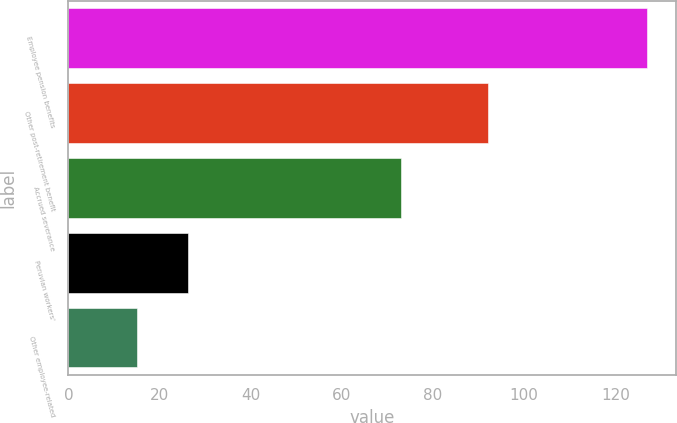Convert chart to OTSL. <chart><loc_0><loc_0><loc_500><loc_500><bar_chart><fcel>Employee pension benefits<fcel>Other post-retirement benefit<fcel>Accrued severance<fcel>Peruvian workers'<fcel>Other employee-related<nl><fcel>127<fcel>92<fcel>73<fcel>26.2<fcel>15<nl></chart> 